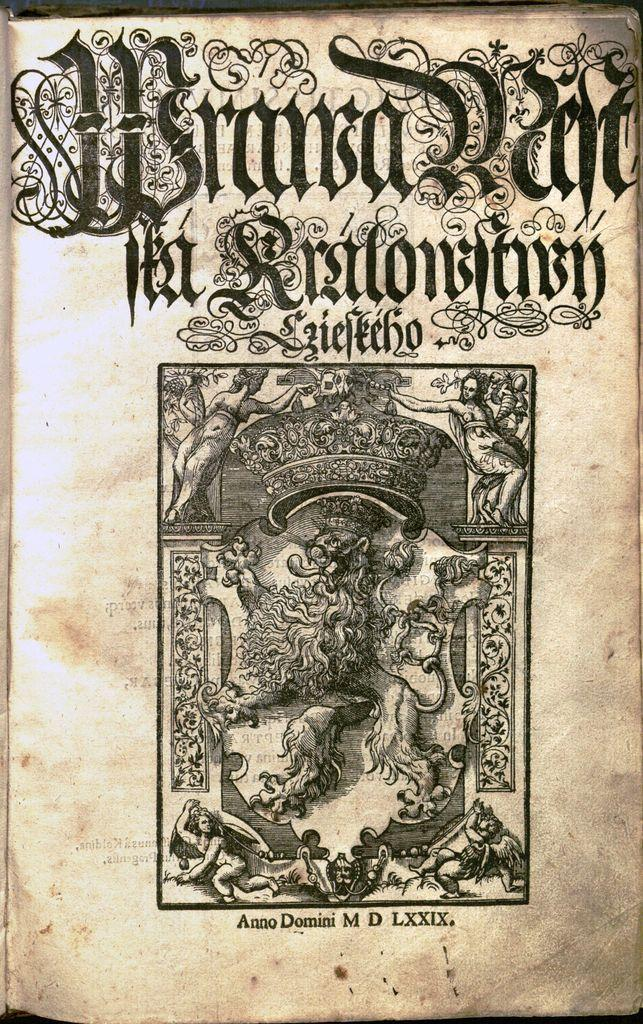<image>
Provide a brief description of the given image. a title page of an ornate script and published in Anno Domini M D LXXIX 